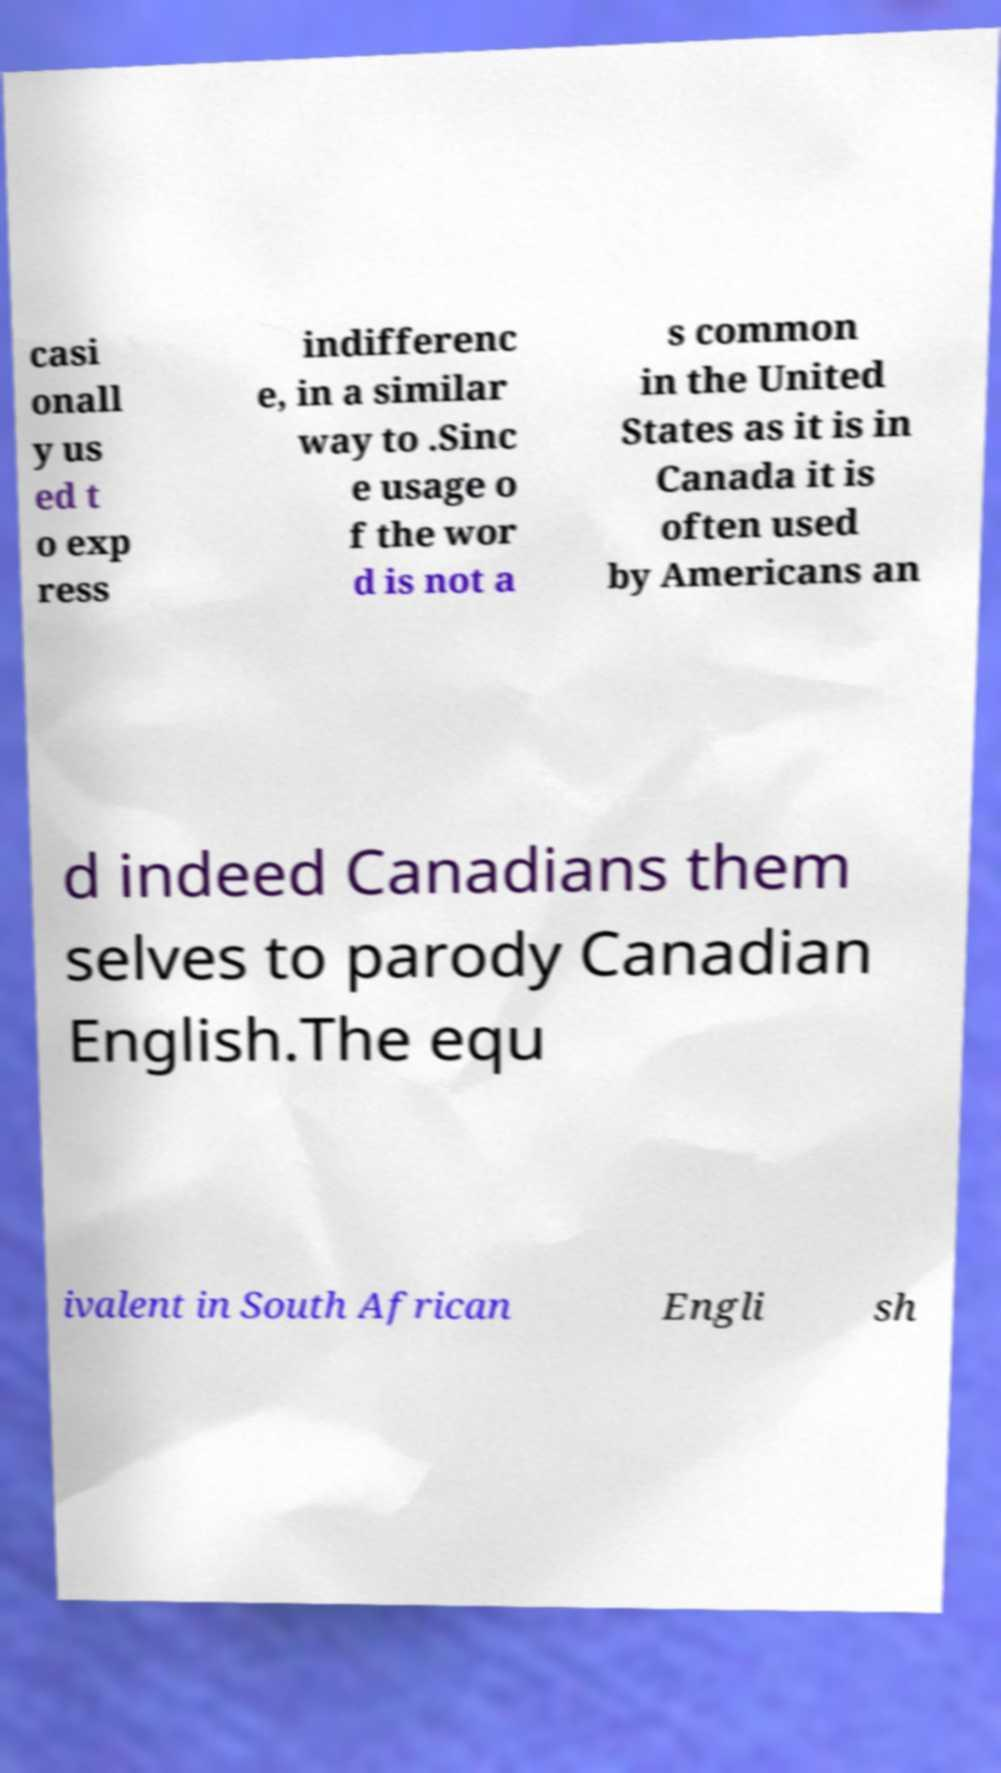Please read and relay the text visible in this image. What does it say? casi onall y us ed t o exp ress indifferenc e, in a similar way to .Sinc e usage o f the wor d is not a s common in the United States as it is in Canada it is often used by Americans an d indeed Canadians them selves to parody Canadian English.The equ ivalent in South African Engli sh 